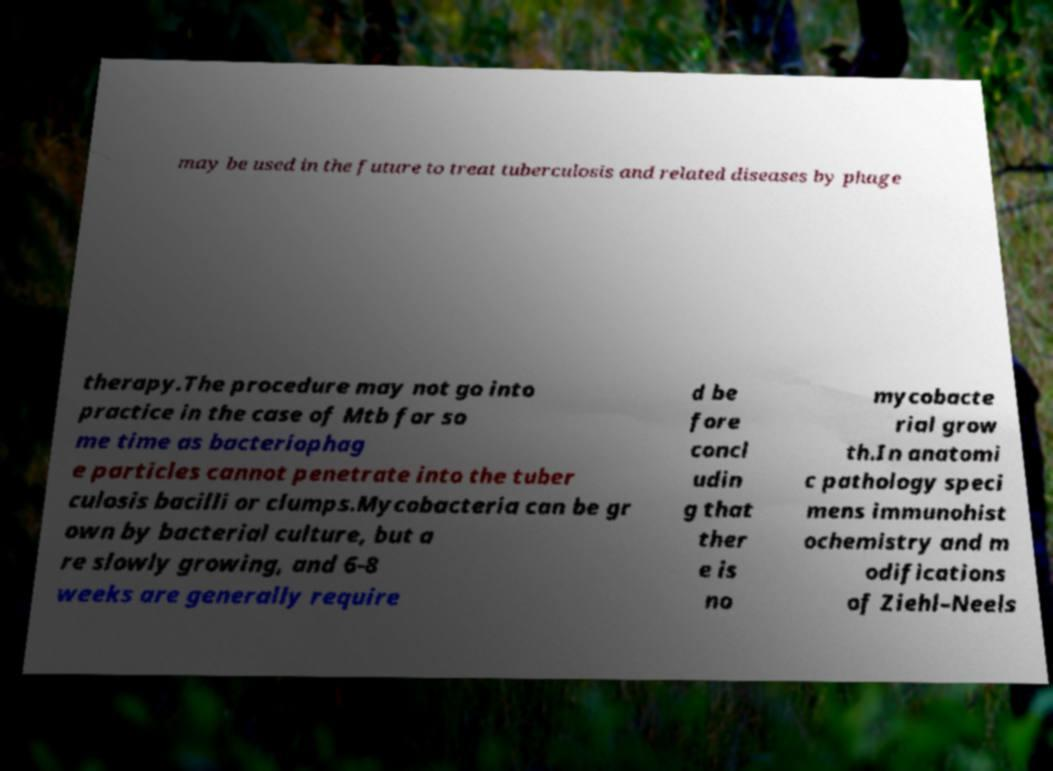For documentation purposes, I need the text within this image transcribed. Could you provide that? may be used in the future to treat tuberculosis and related diseases by phage therapy.The procedure may not go into practice in the case of Mtb for so me time as bacteriophag e particles cannot penetrate into the tuber culosis bacilli or clumps.Mycobacteria can be gr own by bacterial culture, but a re slowly growing, and 6-8 weeks are generally require d be fore concl udin g that ther e is no mycobacte rial grow th.In anatomi c pathology speci mens immunohist ochemistry and m odifications of Ziehl–Neels 